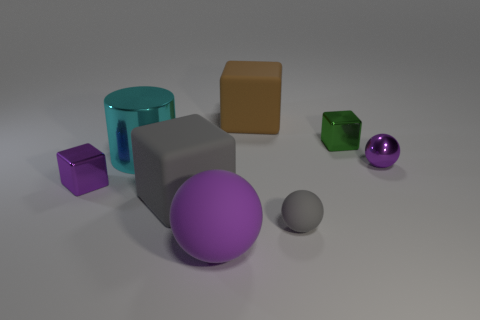How many small matte blocks have the same color as the metallic sphere?
Give a very brief answer. 0. There is a large matte thing to the left of the purple rubber object; does it have the same shape as the small purple metal object right of the big purple matte object?
Offer a terse response. No. What number of purple balls are behind the small purple shiny object to the right of the big rubber block that is left of the big purple thing?
Offer a very short reply. 0. What material is the small thing in front of the purple metal thing on the left side of the small cube that is to the right of the large cyan shiny object?
Make the answer very short. Rubber. Is the material of the small block that is in front of the small purple sphere the same as the gray block?
Keep it short and to the point. No. How many brown rubber things have the same size as the purple matte object?
Make the answer very short. 1. Are there more big gray cubes that are on the left side of the large gray rubber object than purple metallic things that are behind the large brown matte block?
Your answer should be very brief. No. Is there a green object of the same shape as the large brown matte thing?
Your response must be concise. Yes. There is a gray matte thing that is left of the large purple matte thing in front of the big shiny object; what is its size?
Keep it short and to the point. Large. What is the shape of the small purple metal thing that is on the left side of the big block behind the large gray matte block that is behind the small rubber ball?
Your response must be concise. Cube. 